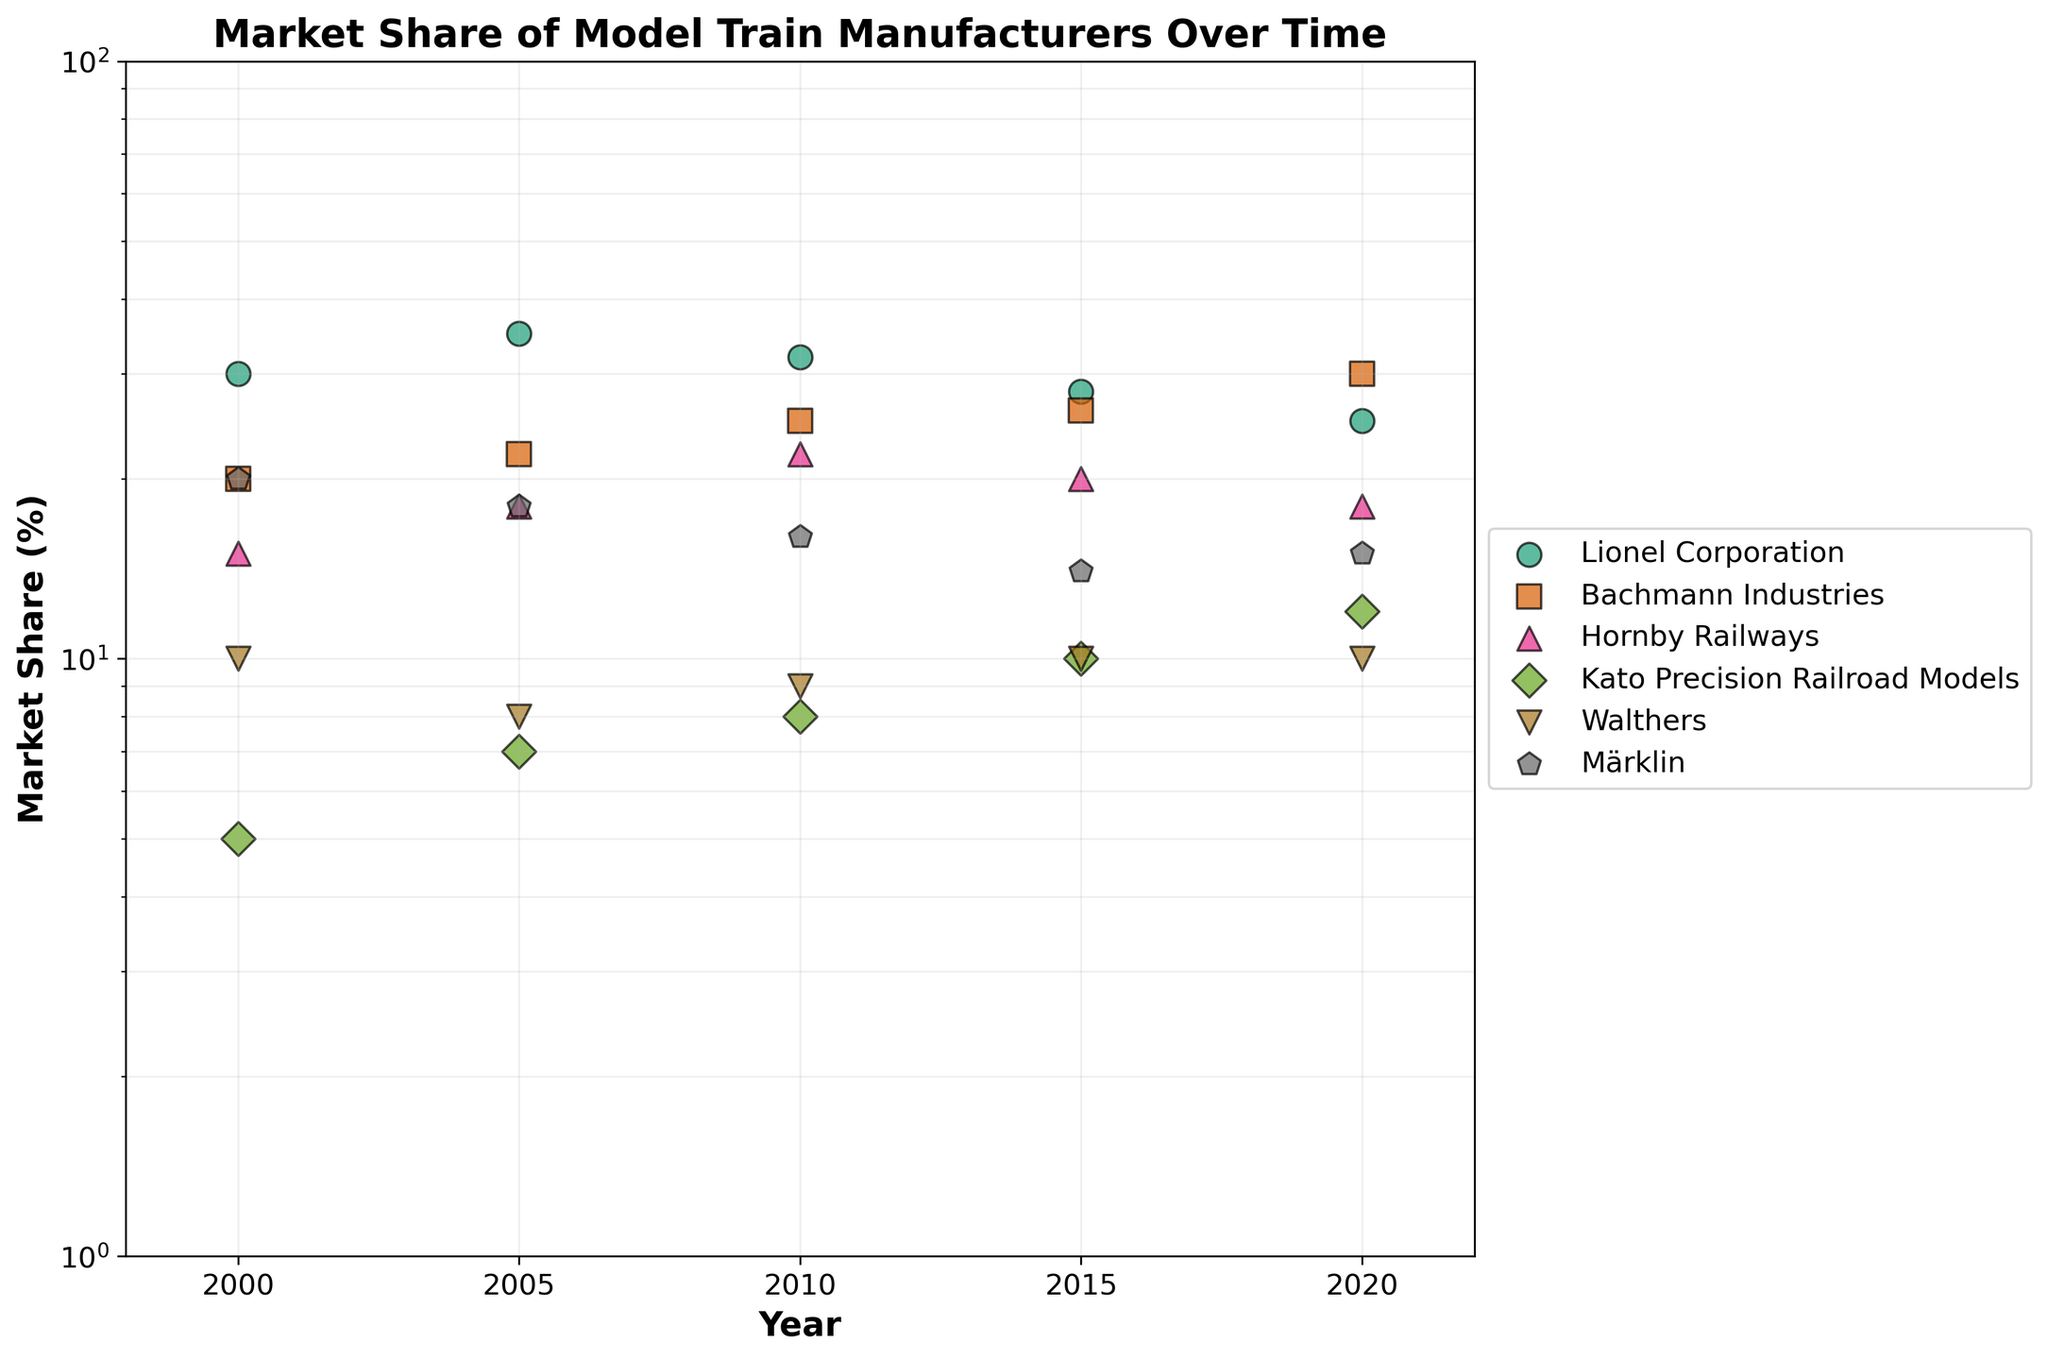What's the title of the scatter plot? The title is usually located at the top center of a plot, and in this case, it reads 'Market Share of Model Train Manufacturers Over Time'.
Answer: Market Share of Model Train Manufacturers Over Time What are the axis labels of the scatter plot? The x-axis label is at the bottom and reads 'Year', and the y-axis label is on the left and reads 'Market Share (%)'.
Answer: Year, Market Share (%) Which manufacturer had the highest market share in 2000? By locating the year 2000 on the x-axis and then observing which scatter point has the highest value, it is clear that 'Lionel Corporation' had the highest market share.
Answer: Lionel Corporation Which manufacturer experienced a consistent increase in market share from 2000 to 2020? By examining the scatter points for each manufacturer over time, 'Bachmann Industries' shows a consistent increase in market share.
Answer: Bachmann Industries Between Bachmann Industries and Hornby Railways, which had a higher market share in 2020? By comparing the 2020 data points (x=2020) for both manufacturers, 'Bachmann Industries' had a higher value than 'Hornby Railways'.
Answer: Bachmann Industries What is the range of market share for Märklin from 2000 to 2020? To find the range, identify the maximum and minimum market share values for Märklin, which are 20% and 14% respectively. The range is the difference between these values, which is 6%.
Answer: 6% Which manufacturer showed a visible decline in market share from 2000 to 2020? By observing the trend lines, 'Lionel Corporation' and 'Märklin' both show a visible decline, but 'Lionel Corporation' had a more pronounced decrease.
Answer: Lionel Corporation How does the market share of Walthers in 2000 compare to that of Kato Precision Railroad Models in 2020? By checking the scatter points for Walthers in 2000 and Kato Precision Railroad Models in 2020, they both share the same market value (10%).
Answer: Same What is the percentage decrease in market share for Lionel Corporation from 2005 to 2020? First, find the market shares for Lionel Corporation in 2005 (35%) and 2020 (25%). The percentage decrease is calculated as ((35 - 25) / 35) * 100 = (10 / 35) * 100 ≈ 28.57%.
Answer: 28.57% Which manufacturer's market share did not change from 2015 to 2020? By examining the scatter points for 2015 and 2020, 'Walthers' had the same market share of 10% in both years.
Answer: Walthers 